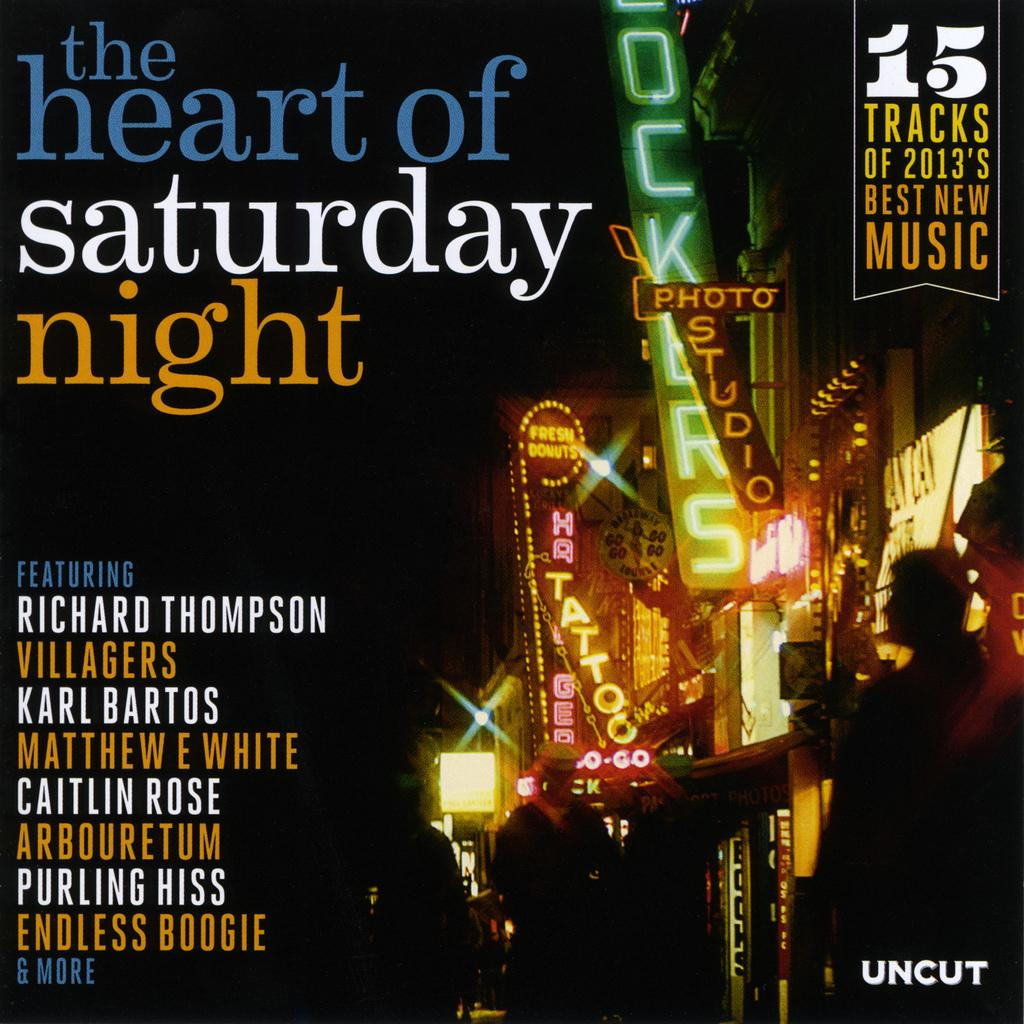Provide a one-sentence caption for the provided image. An uncut album cover featuring the heart of Saturday night. 